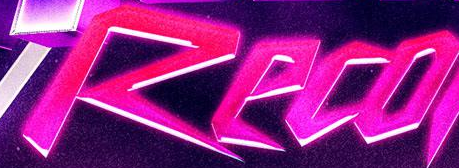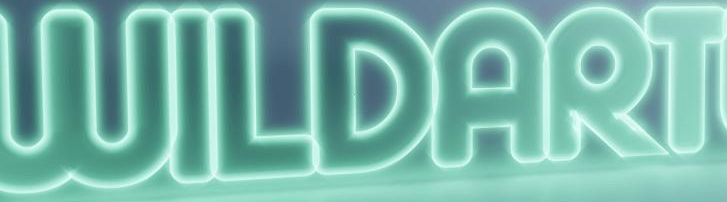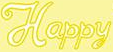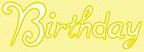Read the text from these images in sequence, separated by a semicolon. Reco; WILDART; Happy; Birthday 